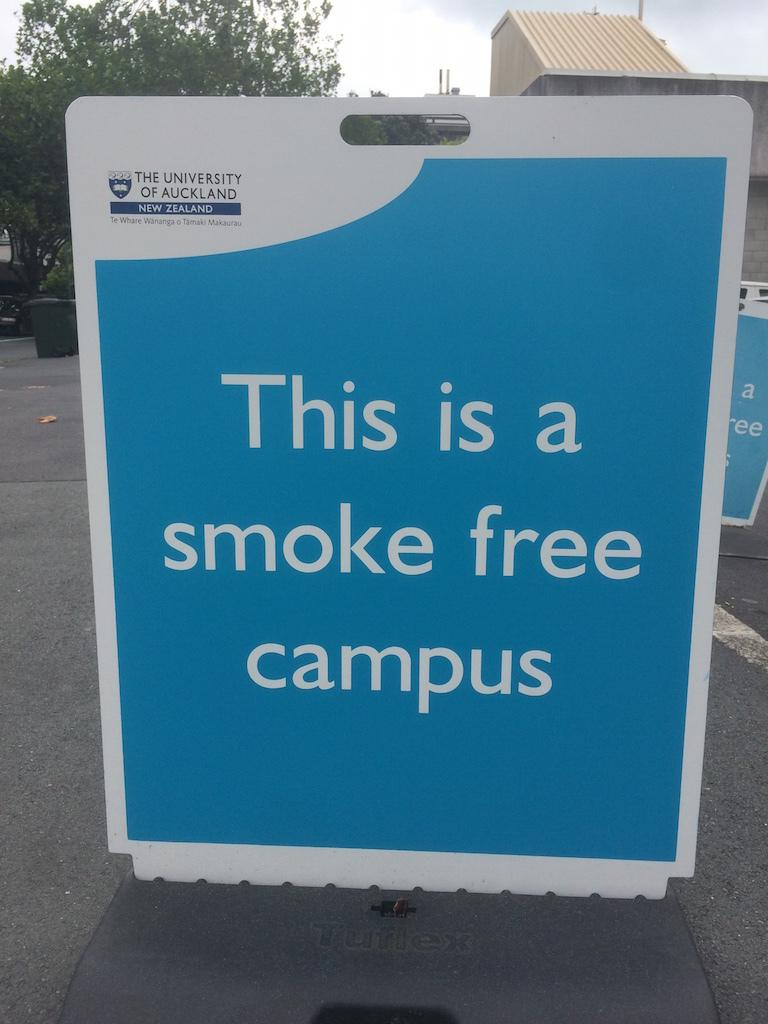<image>
Relay a brief, clear account of the picture shown. a sign that has the word smoke on it 